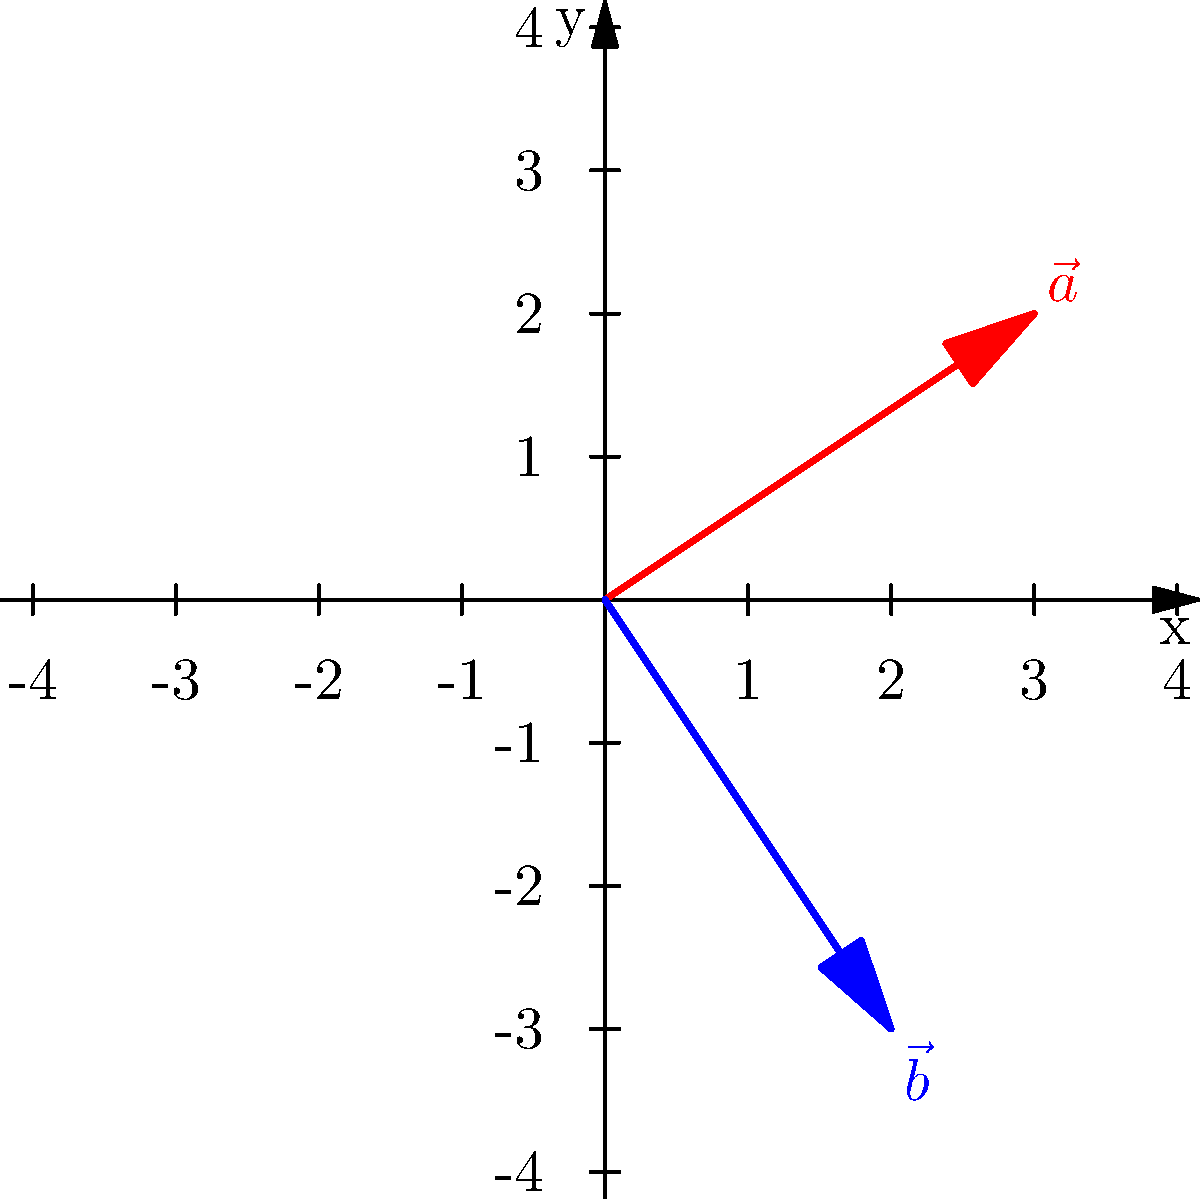In our classroom, we often use visual aids to help students understand mathematical concepts. Consider the grid above, where vector $\vec{a}$ is represented by the red arrow, and vector $\vec{b}$ is represented by the blue arrow. What is the angle between these two vectors, rounded to the nearest degree? To find the angle between two vectors, we can use the dot product formula:

$$\cos \theta = \frac{\vec{a} \cdot \vec{b}}{|\vec{a}| |\vec{b}|}$$

Let's solve this step-by-step:

1) First, we need to determine the components of each vector:
   $\vec{a} = (3, 2)$ and $\vec{b} = (2, -3)$

2) Calculate the dot product $\vec{a} \cdot \vec{b}$:
   $\vec{a} \cdot \vec{b} = (3)(2) + (2)(-3) = 6 - 6 = 0$

3) Calculate the magnitudes of the vectors:
   $|\vec{a}| = \sqrt{3^2 + 2^2} = \sqrt{13}$
   $|\vec{b}| = \sqrt{2^2 + (-3)^2} = \sqrt{13}$

4) Now, let's substitute these values into the formula:
   $$\cos \theta = \frac{0}{\sqrt{13} \cdot \sqrt{13}} = \frac{0}{13} = 0$$

5) To find $\theta$, we need to take the inverse cosine (arccos) of both sides:
   $$\theta = \arccos(0) = 90^\circ$$

Therefore, the angle between the two vectors is 90°.
Answer: 90° 